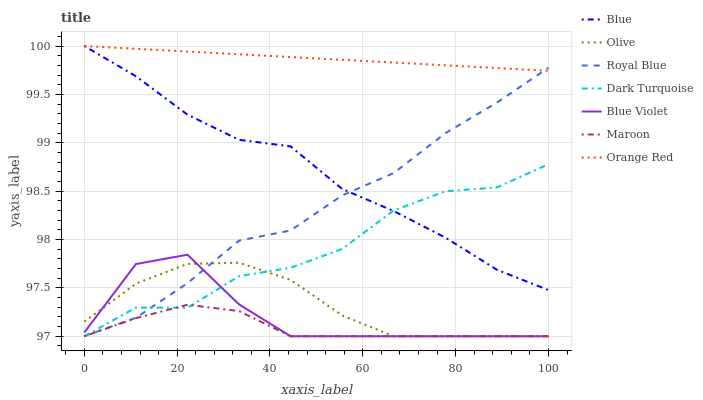Does Maroon have the minimum area under the curve?
Answer yes or no. Yes. Does Orange Red have the maximum area under the curve?
Answer yes or no. Yes. Does Dark Turquoise have the minimum area under the curve?
Answer yes or no. No. Does Dark Turquoise have the maximum area under the curve?
Answer yes or no. No. Is Orange Red the smoothest?
Answer yes or no. Yes. Is Dark Turquoise the roughest?
Answer yes or no. Yes. Is Maroon the smoothest?
Answer yes or no. No. Is Maroon the roughest?
Answer yes or no. No. Does Dark Turquoise have the lowest value?
Answer yes or no. Yes. Does Royal Blue have the lowest value?
Answer yes or no. No. Does Orange Red have the highest value?
Answer yes or no. Yes. Does Dark Turquoise have the highest value?
Answer yes or no. No. Is Blue Violet less than Blue?
Answer yes or no. Yes. Is Blue greater than Blue Violet?
Answer yes or no. Yes. Does Dark Turquoise intersect Maroon?
Answer yes or no. Yes. Is Dark Turquoise less than Maroon?
Answer yes or no. No. Is Dark Turquoise greater than Maroon?
Answer yes or no. No. Does Blue Violet intersect Blue?
Answer yes or no. No. 